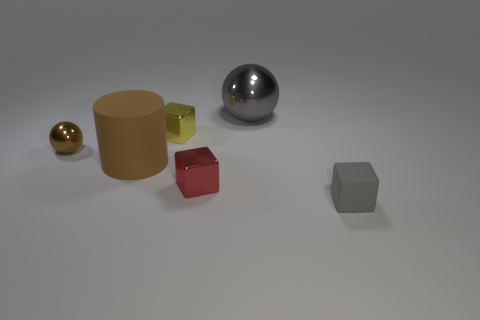Are there an equal number of large rubber cylinders on the left side of the brown cylinder and tiny red cubes in front of the tiny red block?
Your answer should be very brief. Yes. What number of shiny spheres are the same color as the matte cube?
Your response must be concise. 1. What material is the ball that is the same color as the matte cylinder?
Provide a succinct answer. Metal. How many metal things are either gray objects or balls?
Provide a succinct answer. 2. There is a large thing that is in front of the tiny brown ball; is its shape the same as the object that is right of the gray sphere?
Ensure brevity in your answer.  No. What number of tiny cubes are on the left side of the gray rubber block?
Your response must be concise. 2. Is there a large red sphere that has the same material as the gray block?
Offer a terse response. No. There is a gray ball that is the same size as the brown rubber thing; what is it made of?
Offer a very short reply. Metal. Are the cylinder and the large gray object made of the same material?
Your response must be concise. No. How many objects are either big gray metallic cylinders or tiny brown spheres?
Keep it short and to the point. 1. 